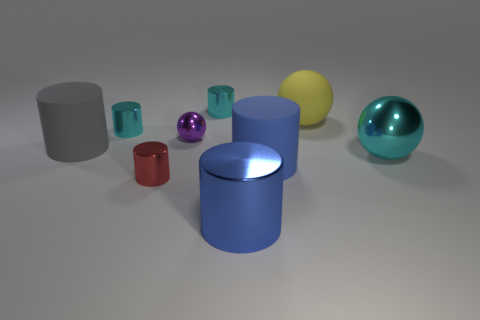Is there anything else that is the same size as the gray matte cylinder?
Offer a very short reply. Yes. Is the number of large rubber cylinders to the left of the red cylinder greater than the number of blue cylinders?
Keep it short and to the point. No. There is a large object that is on the left side of the large blue cylinder in front of the rubber cylinder on the right side of the purple shiny thing; what is its shape?
Make the answer very short. Cylinder. There is a blue object that is on the right side of the blue shiny cylinder; is it the same size as the gray object?
Offer a very short reply. Yes. What shape is the cyan object that is both behind the gray thing and on the right side of the red thing?
Your answer should be very brief. Cylinder. There is a small metallic sphere; does it have the same color as the cylinder behind the large rubber ball?
Provide a short and direct response. No. The small thing left of the small cylinder that is in front of the large blue rubber object that is behind the big blue metallic cylinder is what color?
Offer a terse response. Cyan. There is another rubber thing that is the same shape as the big gray object; what is its color?
Ensure brevity in your answer.  Blue. Are there the same number of purple things that are in front of the blue matte thing and small red blocks?
Provide a short and direct response. Yes. What number of blocks are either big yellow matte things or small brown rubber objects?
Keep it short and to the point. 0. 